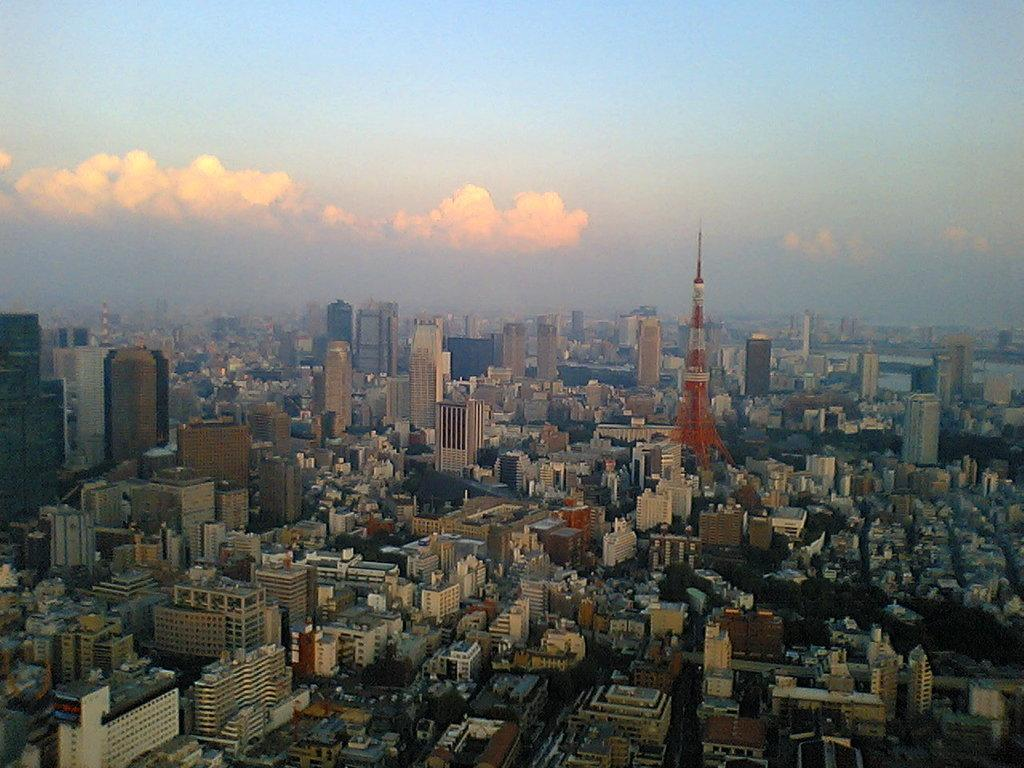What type of structures can be seen in the picture? There are buildings in the picture. What other natural elements are present in the picture? There are trees in the picture. How would you describe the weather based on the sky in the picture? The sky is clear in the picture, suggesting good weather. Where is the boat located in the picture? There is no boat present in the picture. What type of lace can be seen on the trees in the picture? There is no lace present on the trees in the picture. 